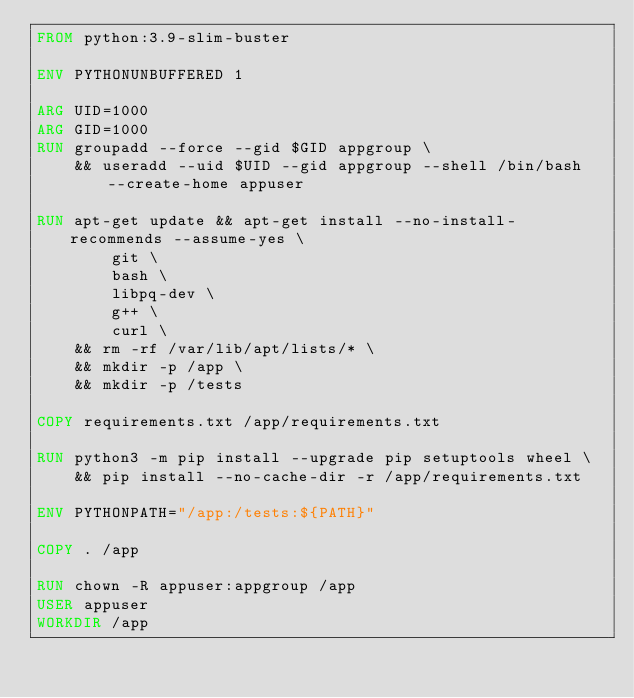<code> <loc_0><loc_0><loc_500><loc_500><_Dockerfile_>FROM python:3.9-slim-buster

ENV PYTHONUNBUFFERED 1

ARG UID=1000
ARG GID=1000
RUN groupadd --force --gid $GID appgroup \
    && useradd --uid $UID --gid appgroup --shell /bin/bash --create-home appuser

RUN apt-get update && apt-get install --no-install-recommends --assume-yes \
        git \
        bash \
        libpq-dev \
        g++ \
        curl \
    && rm -rf /var/lib/apt/lists/* \
    && mkdir -p /app \
    && mkdir -p /tests

COPY requirements.txt /app/requirements.txt

RUN python3 -m pip install --upgrade pip setuptools wheel \
    && pip install --no-cache-dir -r /app/requirements.txt

ENV PYTHONPATH="/app:/tests:${PATH}"

COPY . /app

RUN chown -R appuser:appgroup /app
USER appuser
WORKDIR /app
</code> 